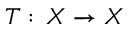Convert formula to latex. <formula><loc_0><loc_0><loc_500><loc_500>T \colon \, X \to X</formula> 